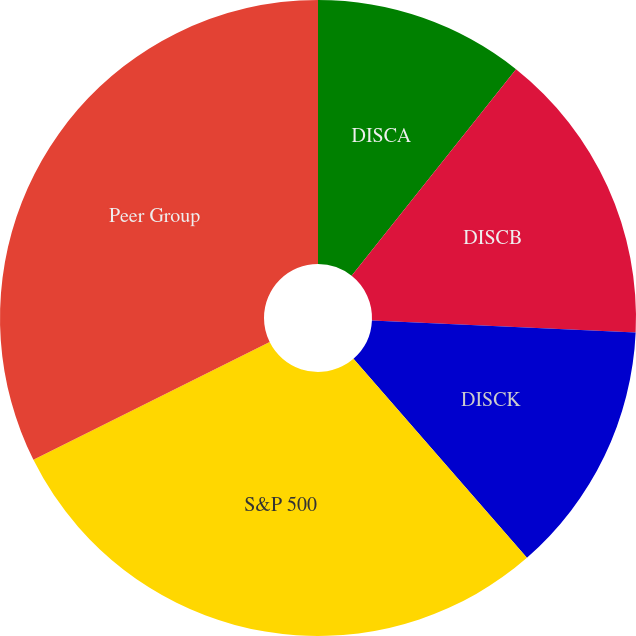Convert chart to OTSL. <chart><loc_0><loc_0><loc_500><loc_500><pie_chart><fcel>DISCA<fcel>DISCB<fcel>DISCK<fcel>S&P 500<fcel>Peer Group<nl><fcel>10.7%<fcel>15.03%<fcel>12.86%<fcel>29.05%<fcel>32.36%<nl></chart> 